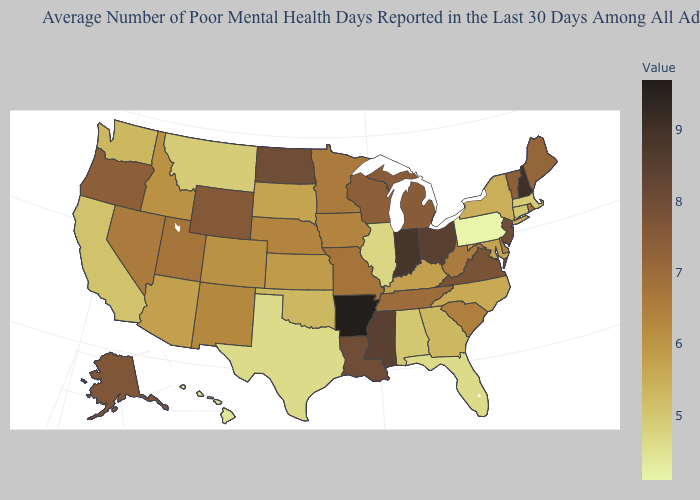Among the states that border South Dakota , does Minnesota have the highest value?
Be succinct. No. Does Kentucky have the highest value in the USA?
Concise answer only. No. 